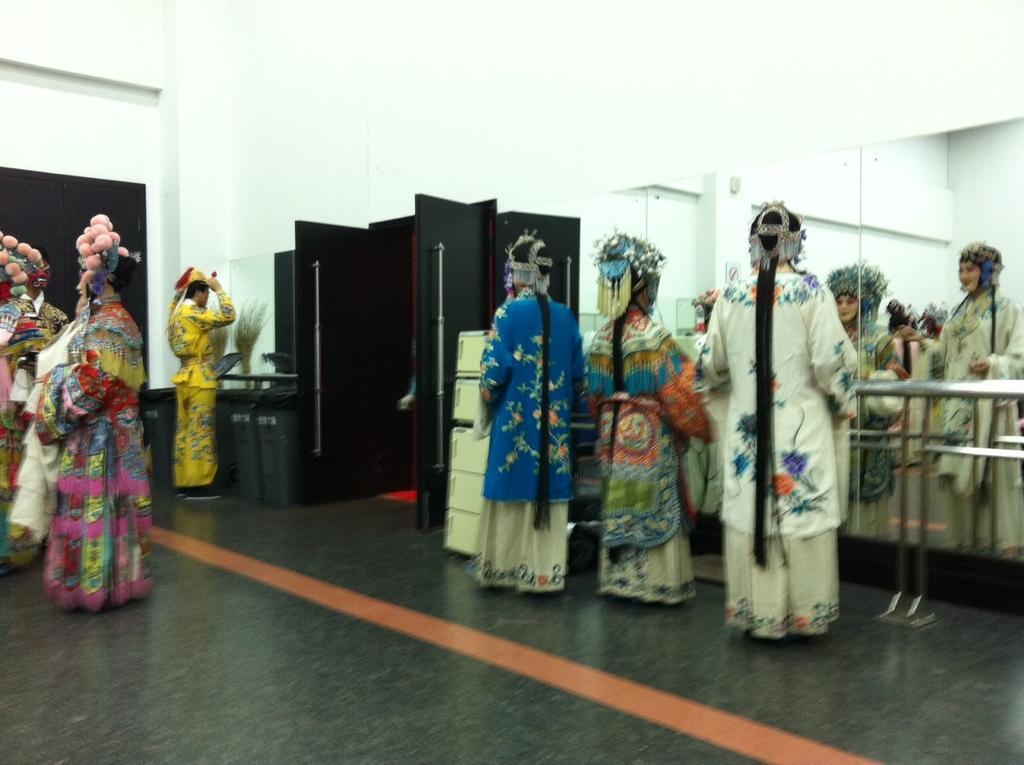Describe this image in one or two sentences. This picture is an inside view of a room. In this picture we can see some persons wearing costumes. In the background of the image we can see wall, door, mirrors, grills, board. At the top of the image there is a roof. At the bottom of the image there is a floor. 